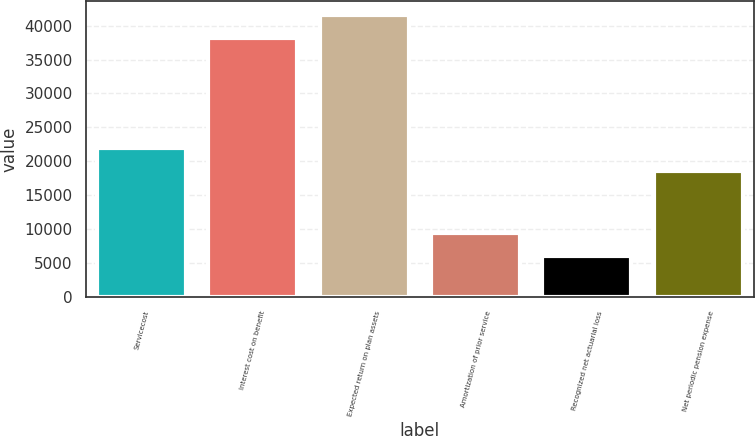<chart> <loc_0><loc_0><loc_500><loc_500><bar_chart><fcel>Servicecost<fcel>Interest cost on benefit<fcel>Expected return on plan assets<fcel>Amortization of prior service<fcel>Recognized net actuarial loss<fcel>Net periodic pension expense<nl><fcel>21955.9<fcel>38120<fcel>41535.9<fcel>9408.9<fcel>5993<fcel>18540<nl></chart> 